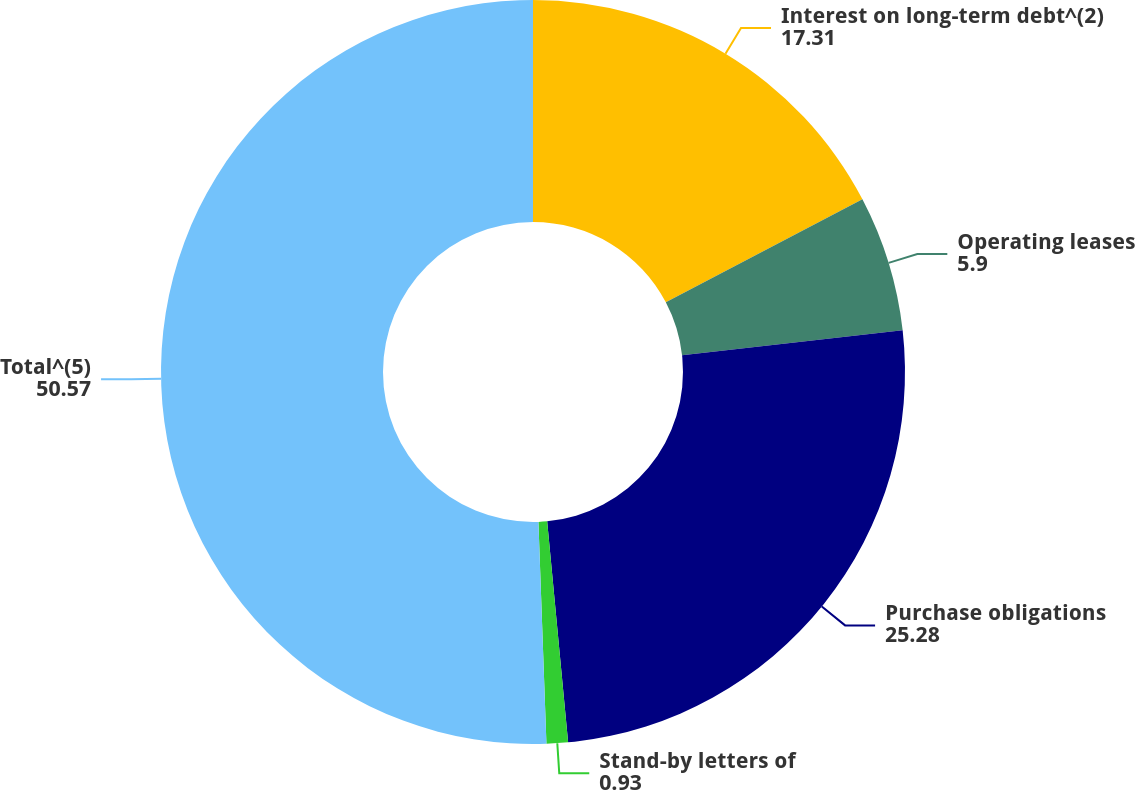Convert chart. <chart><loc_0><loc_0><loc_500><loc_500><pie_chart><fcel>Interest on long-term debt^(2)<fcel>Operating leases<fcel>Purchase obligations<fcel>Stand-by letters of<fcel>Total^(5)<nl><fcel>17.31%<fcel>5.9%<fcel>25.28%<fcel>0.93%<fcel>50.57%<nl></chart> 